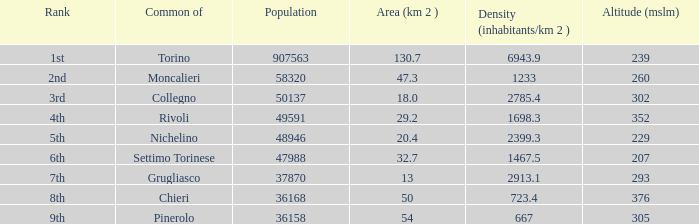Parse the full table. {'header': ['Rank', 'Common of', 'Population', 'Area (km 2 )', 'Density (inhabitants/km 2 )', 'Altitude (mslm)'], 'rows': [['1st', 'Torino', '907563', '130.7', '6943.9', '239'], ['2nd', 'Moncalieri', '58320', '47.3', '1233', '260'], ['3rd', 'Collegno', '50137', '18.0', '2785.4', '302'], ['4th', 'Rivoli', '49591', '29.2', '1698.3', '352'], ['5th', 'Nichelino', '48946', '20.4', '2399.3', '229'], ['6th', 'Settimo Torinese', '47988', '32.7', '1467.5', '207'], ['7th', 'Grugliasco', '37870', '13', '2913.1', '293'], ['8th', 'Chieri', '36168', '50', '723.4', '376'], ['9th', 'Pinerolo', '36158', '54', '667', '305']]} How may population figures are given for Settimo Torinese 1.0. 